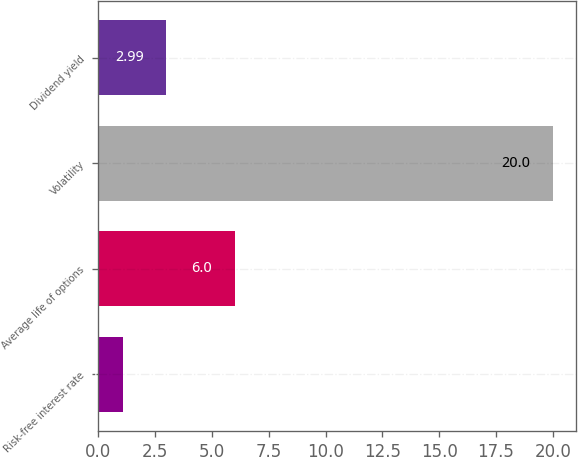<chart> <loc_0><loc_0><loc_500><loc_500><bar_chart><fcel>Risk-free interest rate<fcel>Average life of options<fcel>Volatility<fcel>Dividend yield<nl><fcel>1.1<fcel>6<fcel>20<fcel>2.99<nl></chart> 